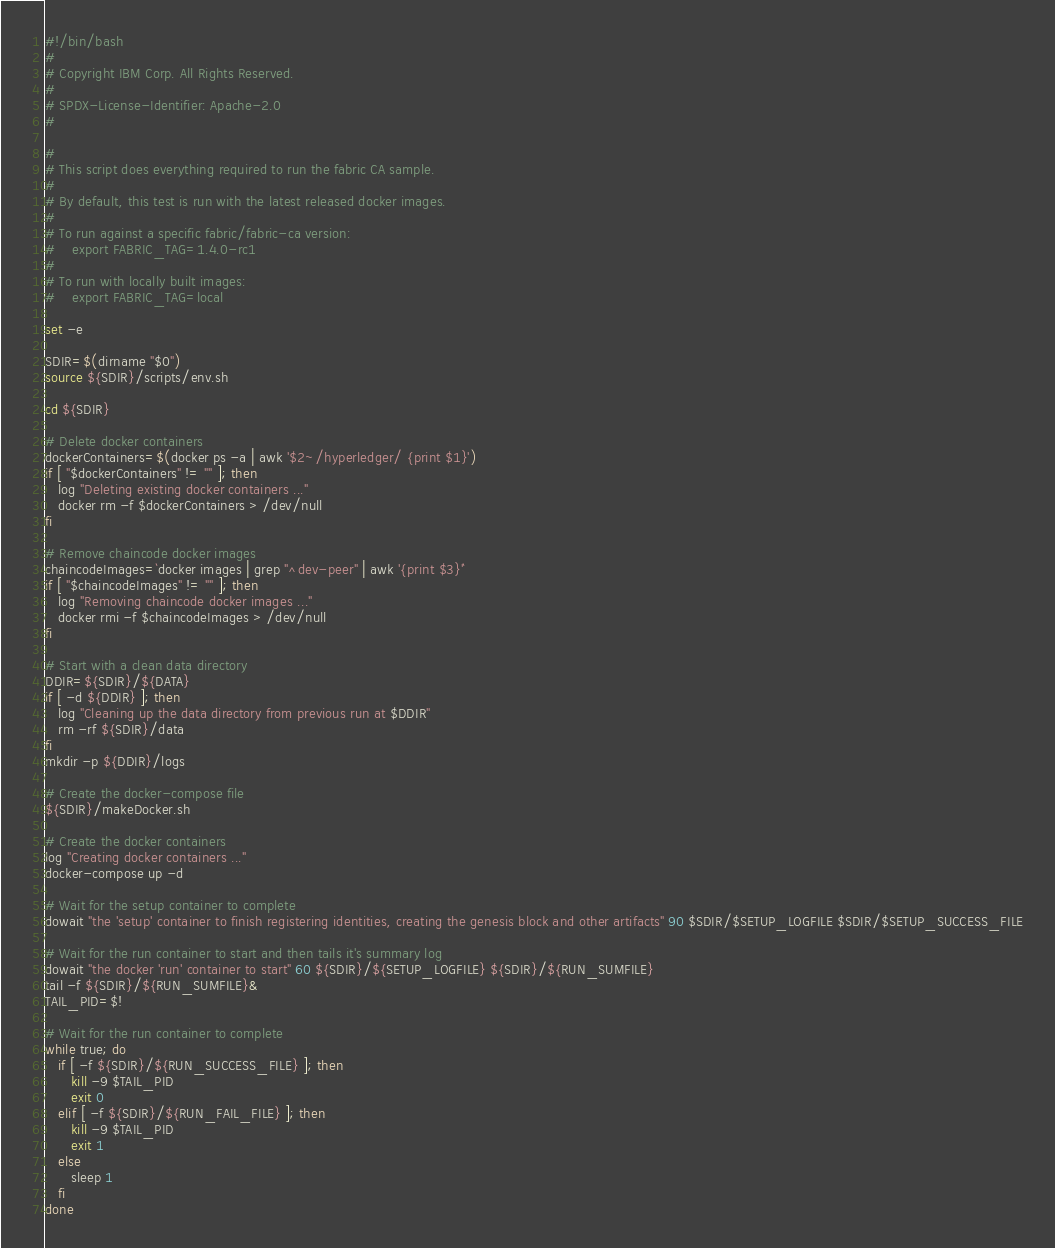Convert code to text. <code><loc_0><loc_0><loc_500><loc_500><_Bash_>#!/bin/bash
#
# Copyright IBM Corp. All Rights Reserved.
#
# SPDX-License-Identifier: Apache-2.0
#

#
# This script does everything required to run the fabric CA sample.
#
# By default, this test is run with the latest released docker images.
#
# To run against a specific fabric/fabric-ca version:
#    export FABRIC_TAG=1.4.0-rc1
#
# To run with locally built images:
#    export FABRIC_TAG=local

set -e

SDIR=$(dirname "$0")
source ${SDIR}/scripts/env.sh

cd ${SDIR}

# Delete docker containers
dockerContainers=$(docker ps -a | awk '$2~/hyperledger/ {print $1}')
if [ "$dockerContainers" != "" ]; then
   log "Deleting existing docker containers ..."
   docker rm -f $dockerContainers > /dev/null
fi

# Remove chaincode docker images
chaincodeImages=`docker images | grep "^dev-peer" | awk '{print $3}'`
if [ "$chaincodeImages" != "" ]; then
   log "Removing chaincode docker images ..."
   docker rmi -f $chaincodeImages > /dev/null
fi

# Start with a clean data directory
DDIR=${SDIR}/${DATA}
if [ -d ${DDIR} ]; then
   log "Cleaning up the data directory from previous run at $DDIR"
   rm -rf ${SDIR}/data
fi
mkdir -p ${DDIR}/logs

# Create the docker-compose file
${SDIR}/makeDocker.sh

# Create the docker containers
log "Creating docker containers ..."
docker-compose up -d

# Wait for the setup container to complete
dowait "the 'setup' container to finish registering identities, creating the genesis block and other artifacts" 90 $SDIR/$SETUP_LOGFILE $SDIR/$SETUP_SUCCESS_FILE

# Wait for the run container to start and then tails it's summary log
dowait "the docker 'run' container to start" 60 ${SDIR}/${SETUP_LOGFILE} ${SDIR}/${RUN_SUMFILE}
tail -f ${SDIR}/${RUN_SUMFILE}&
TAIL_PID=$!

# Wait for the run container to complete
while true; do
   if [ -f ${SDIR}/${RUN_SUCCESS_FILE} ]; then
      kill -9 $TAIL_PID
      exit 0
   elif [ -f ${SDIR}/${RUN_FAIL_FILE} ]; then
      kill -9 $TAIL_PID
      exit 1
   else
      sleep 1
   fi
done
</code> 